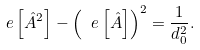<formula> <loc_0><loc_0><loc_500><loc_500>\ e \left [ \hat { A } ^ { 2 } \right ] - \left ( \ e \left [ \hat { A } \right ] \right ) ^ { 2 } = \frac { 1 } { d _ { 0 } ^ { 2 } } .</formula> 